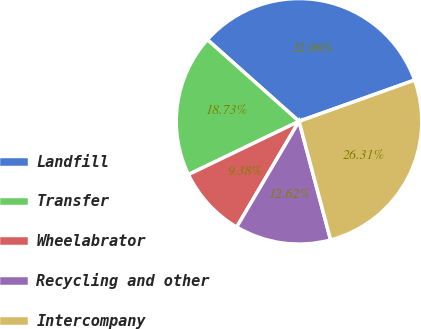Convert chart to OTSL. <chart><loc_0><loc_0><loc_500><loc_500><pie_chart><fcel>Landfill<fcel>Transfer<fcel>Wheelabrator<fcel>Recycling and other<fcel>Intercompany<nl><fcel>32.96%<fcel>18.73%<fcel>9.38%<fcel>12.62%<fcel>26.31%<nl></chart> 